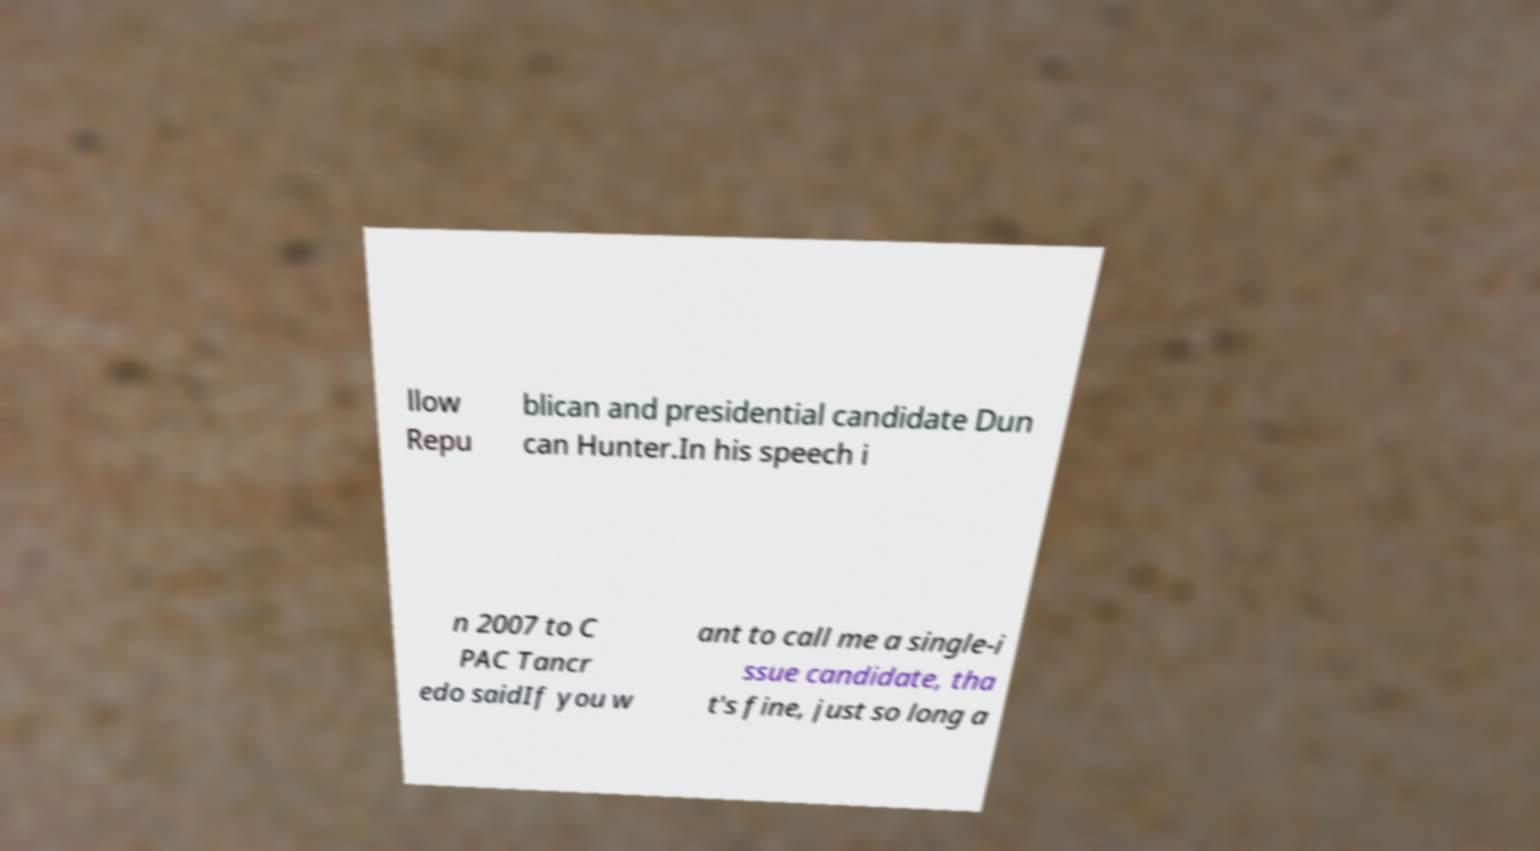What messages or text are displayed in this image? I need them in a readable, typed format. llow Repu blican and presidential candidate Dun can Hunter.In his speech i n 2007 to C PAC Tancr edo saidIf you w ant to call me a single-i ssue candidate, tha t's fine, just so long a 